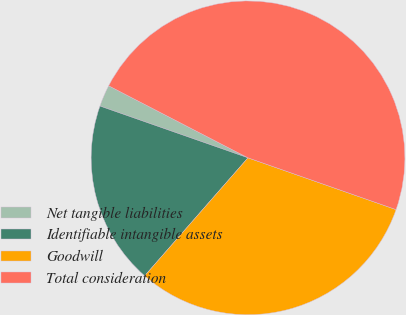Convert chart to OTSL. <chart><loc_0><loc_0><loc_500><loc_500><pie_chart><fcel>Net tangible liabilities<fcel>Identifiable intangible assets<fcel>Goodwill<fcel>Total consideration<nl><fcel>2.24%<fcel>18.91%<fcel>31.09%<fcel>47.76%<nl></chart> 